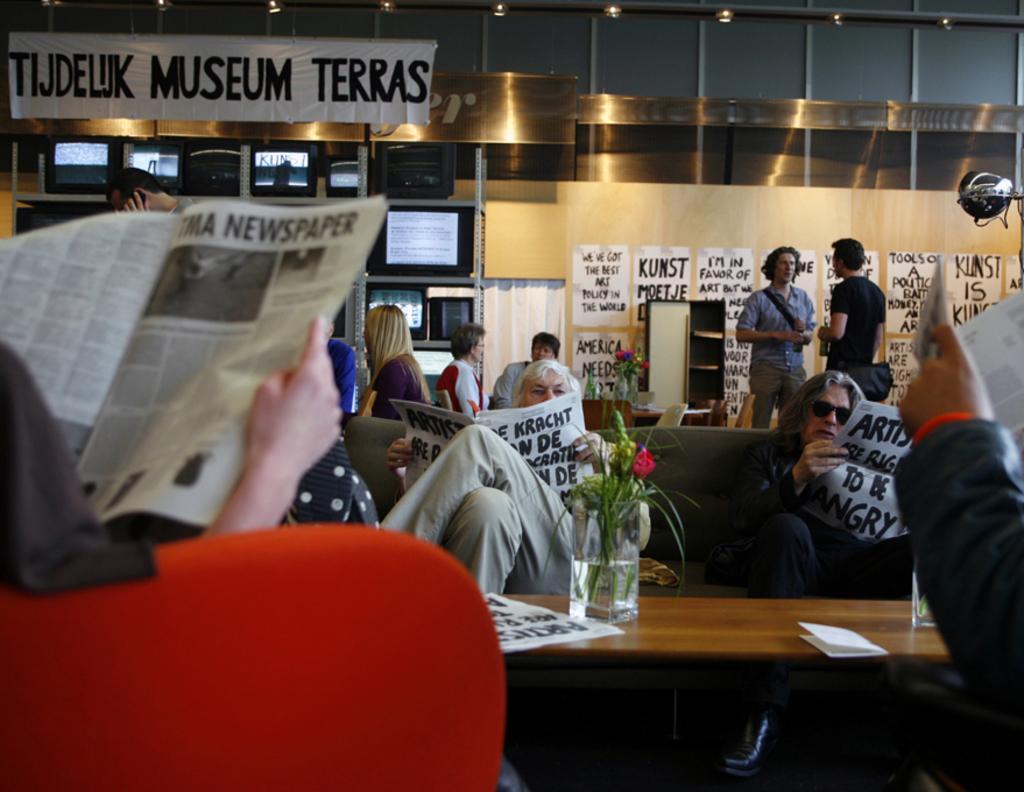Please provide a concise description of this image. Here some people are there. Two people are sitting on the sofa and they are reading newspaper. In front of them there is table. On the table there is a flower vase and a paper. And to the left bottom corner there is a sofa and in the sofa there is a person sitting and reading newspaper. On right side there is another man. And in the background there are two men are standing. Into wall there are some posters. On the top left corner there is a banner. 